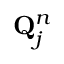<formula> <loc_0><loc_0><loc_500><loc_500>Q _ { j } ^ { n }</formula> 